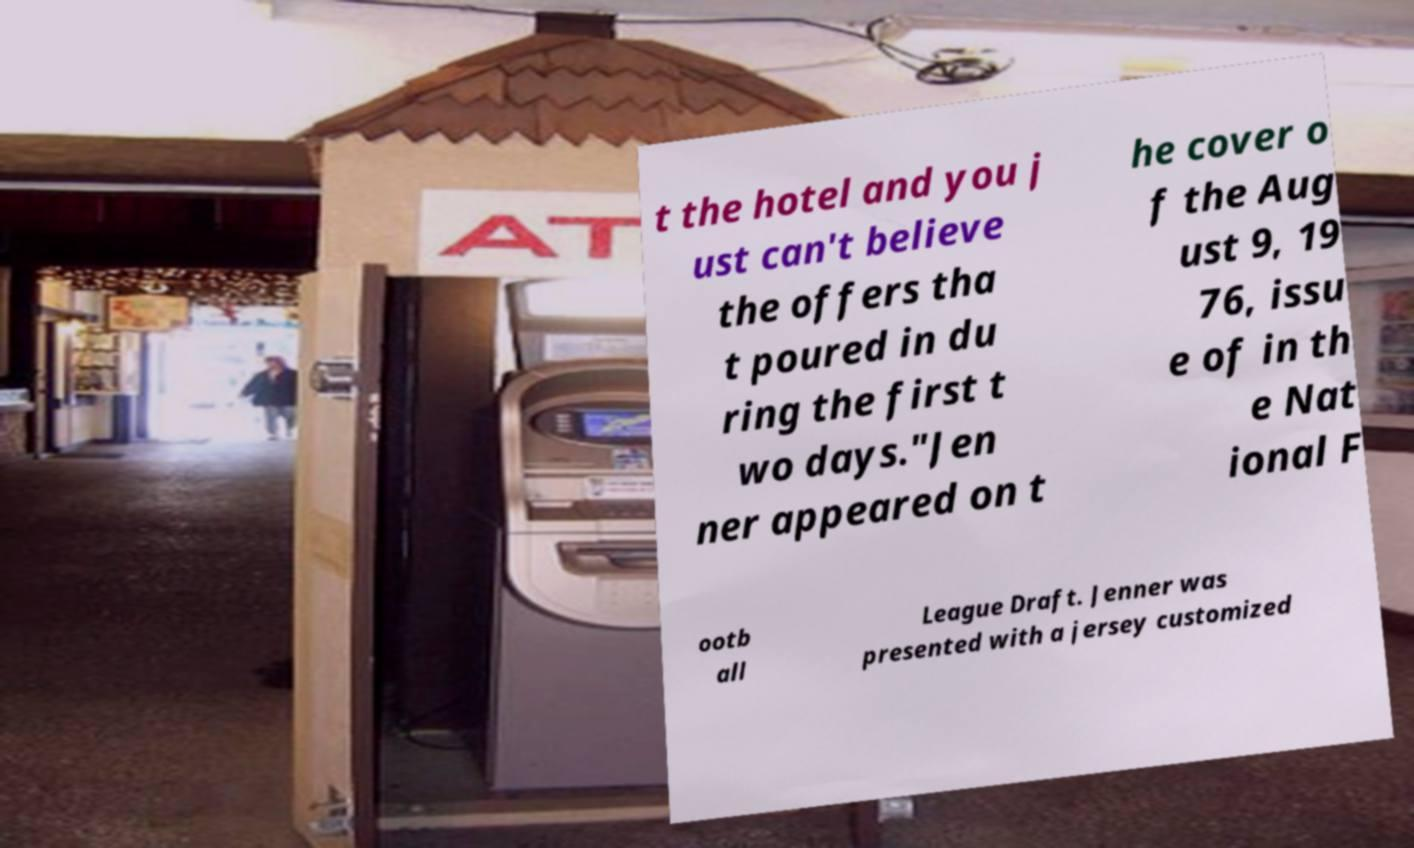Please read and relay the text visible in this image. What does it say? t the hotel and you j ust can't believe the offers tha t poured in du ring the first t wo days."Jen ner appeared on t he cover o f the Aug ust 9, 19 76, issu e of in th e Nat ional F ootb all League Draft. Jenner was presented with a jersey customized 